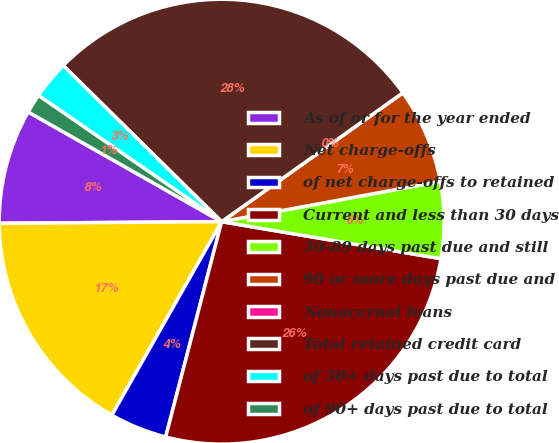<chart> <loc_0><loc_0><loc_500><loc_500><pie_chart><fcel>As of or for the year ended<fcel>Net charge-offs<fcel>of net charge-offs to retained<fcel>Current and less than 30 days<fcel>30-89 days past due and still<fcel>90 or more days past due and<fcel>Nonaccrual loans<fcel>Total retained credit card<fcel>of 30+ days past due to total<fcel>of 90+ days past due to total<nl><fcel>8.33%<fcel>16.67%<fcel>4.17%<fcel>26.39%<fcel>5.56%<fcel>6.94%<fcel>0.0%<fcel>27.78%<fcel>2.78%<fcel>1.39%<nl></chart> 